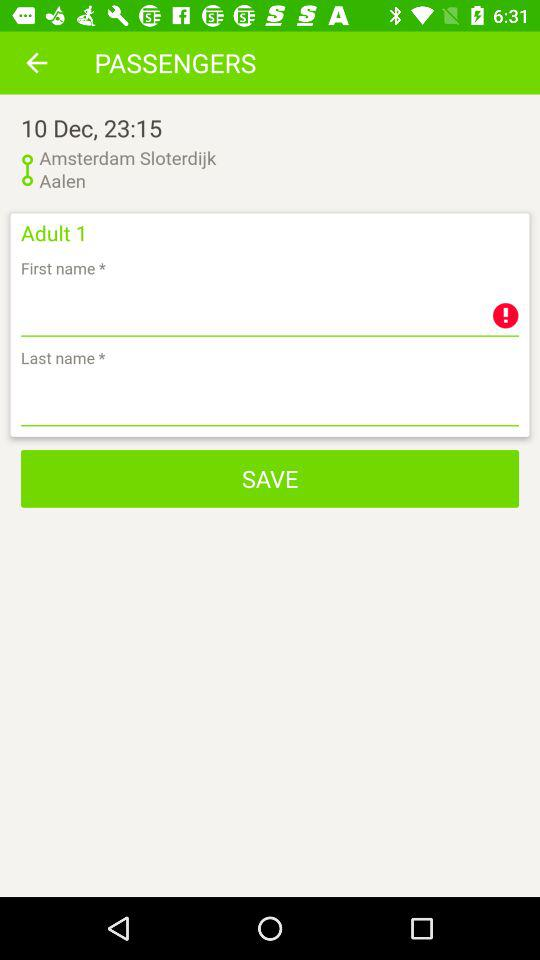How many adults are shown here?
When the provided information is insufficient, respond with <no answer>. <no answer> 